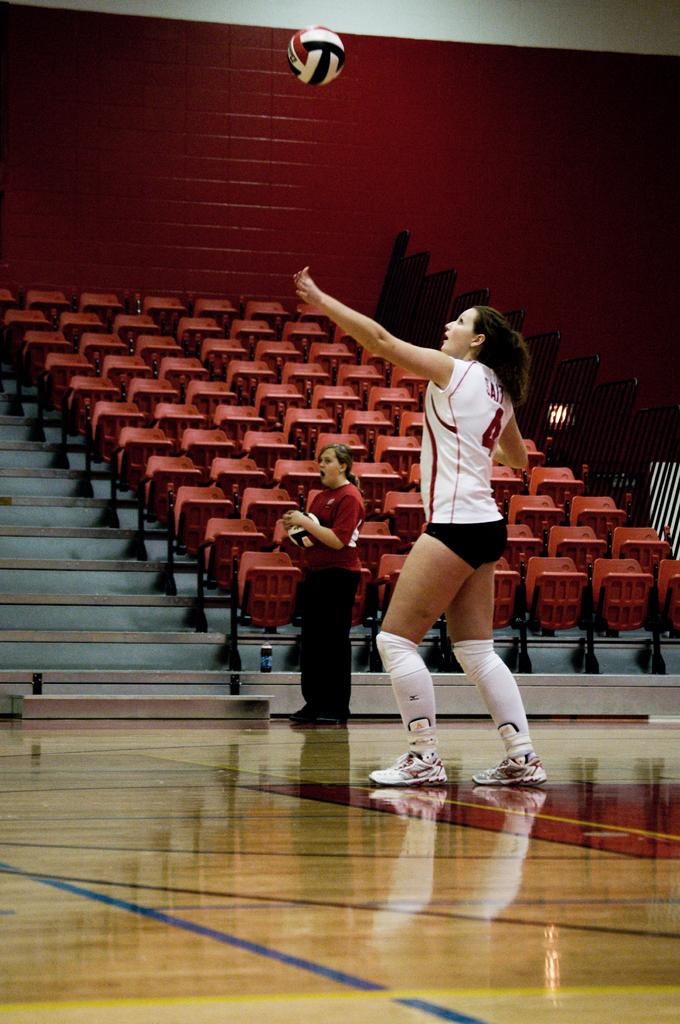How many women are in the image? There are two women in the image. What are the women wearing? The women are wearing clothes and shoes. What objects related to volleyball can be seen in the image? There are two volleyballs in the image. What type of furniture is present in the image? There are chairs in the image. What architectural feature is visible in the image? There are stairs in the image. What is the setting for the volleyball game? There is a volleyball court in the image. What structures are present to enclose or separate the area? There is a fence and a wall in the image. Can you tell me how many crows are sitting on the wall in the image? There are no crows present in the image; it features two women, volleyball-related objects, chairs, stairs, a volleyball court, a fence, and a wall. 